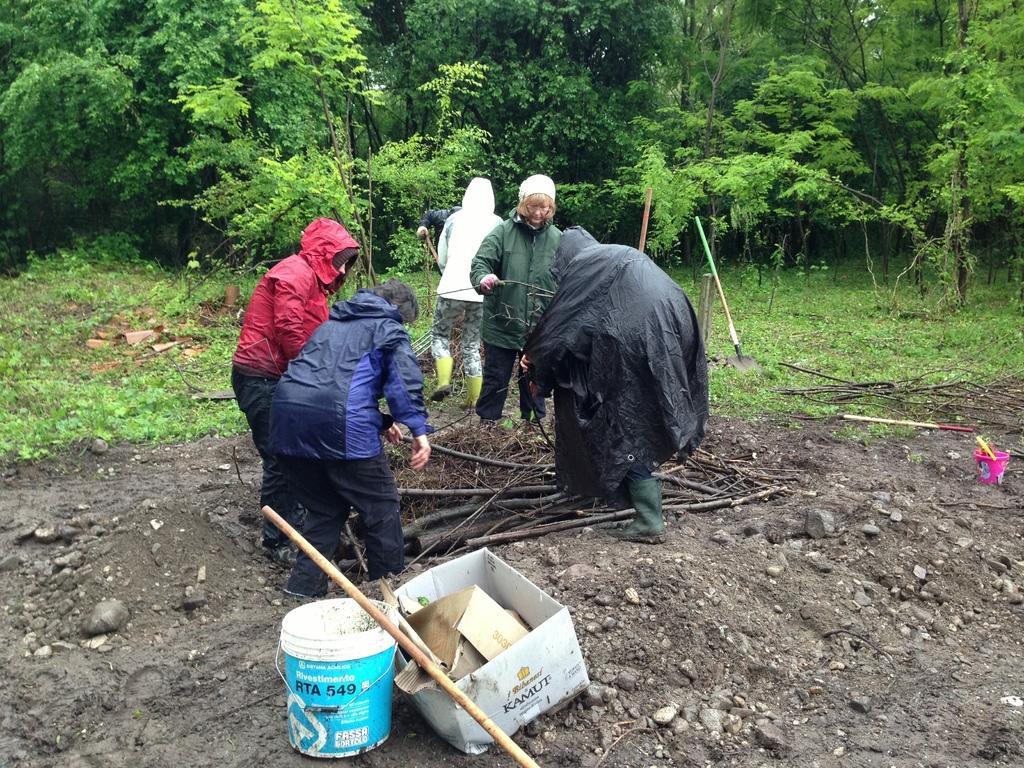Please provide a concise description of this image. In this image I can see a blue colour bucket, a white colour box and a stick in the front. Behind it I can see few people are standing and I can see all of them are wearing jackets. In the background I can see number of trees, grass, a tool and on the right side of this image I can see a pink colour thing. 